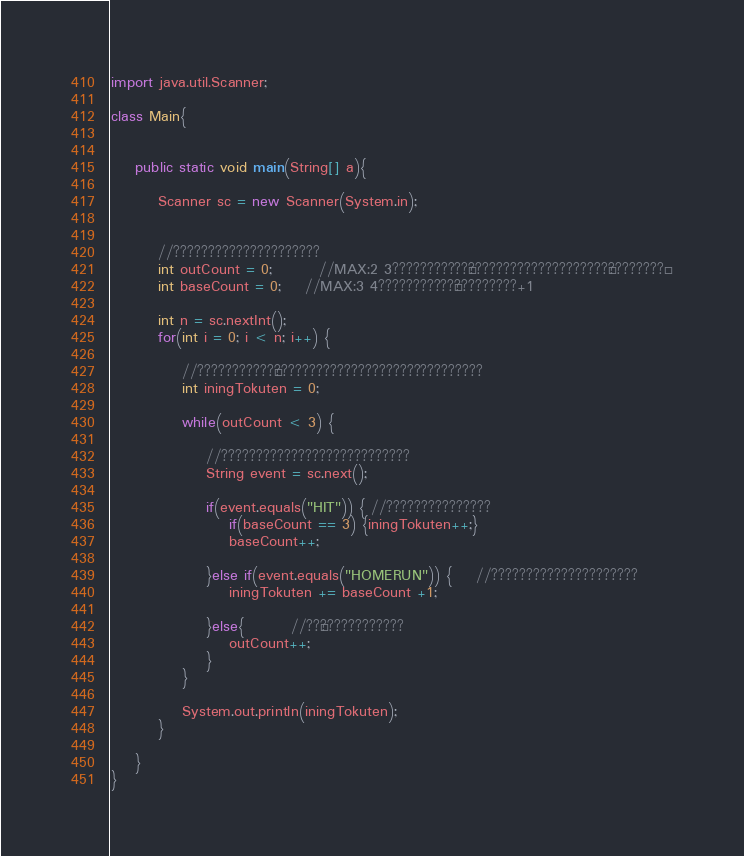Convert code to text. <code><loc_0><loc_0><loc_500><loc_500><_Java_>import java.util.Scanner;

class Main{


	public static void main(String[] a){

		Scanner sc = new Scanner(System.in);


		//?????????????????????
		int outCount = 0;		//MAX:2 3???????????¨????????????????????°????????´
		int baseCount = 0;	//MAX:3 4???????????¨?????????+1

		int n = sc.nextInt();
		for(int i = 0; i < n; i++) {

			//???????????°??????????????????????????????
			int iningTokuten = 0;

			while(outCount < 3) {

				//???????????????????????????
				String event = sc.next();

				if(event.equals("HIT")) { //???????????????
					if(baseCount == 3) {iningTokuten++;}
					baseCount++;

				}else if(event.equals("HOMERUN")) {	//?????????????????????
					iningTokuten += baseCount +1;

				}else{		//??¢????????????
					outCount++;
				}
			}

			System.out.println(iningTokuten);
		}

	}
}</code> 